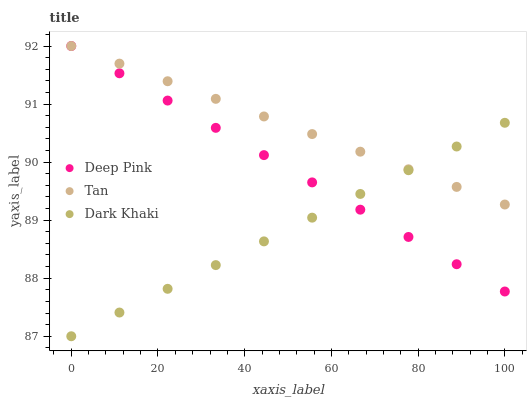Does Dark Khaki have the minimum area under the curve?
Answer yes or no. Yes. Does Tan have the maximum area under the curve?
Answer yes or no. Yes. Does Deep Pink have the minimum area under the curve?
Answer yes or no. No. Does Deep Pink have the maximum area under the curve?
Answer yes or no. No. Is Dark Khaki the smoothest?
Answer yes or no. Yes. Is Deep Pink the roughest?
Answer yes or no. Yes. Is Tan the smoothest?
Answer yes or no. No. Is Tan the roughest?
Answer yes or no. No. Does Dark Khaki have the lowest value?
Answer yes or no. Yes. Does Deep Pink have the lowest value?
Answer yes or no. No. Does Deep Pink have the highest value?
Answer yes or no. Yes. Does Tan intersect Deep Pink?
Answer yes or no. Yes. Is Tan less than Deep Pink?
Answer yes or no. No. Is Tan greater than Deep Pink?
Answer yes or no. No. 